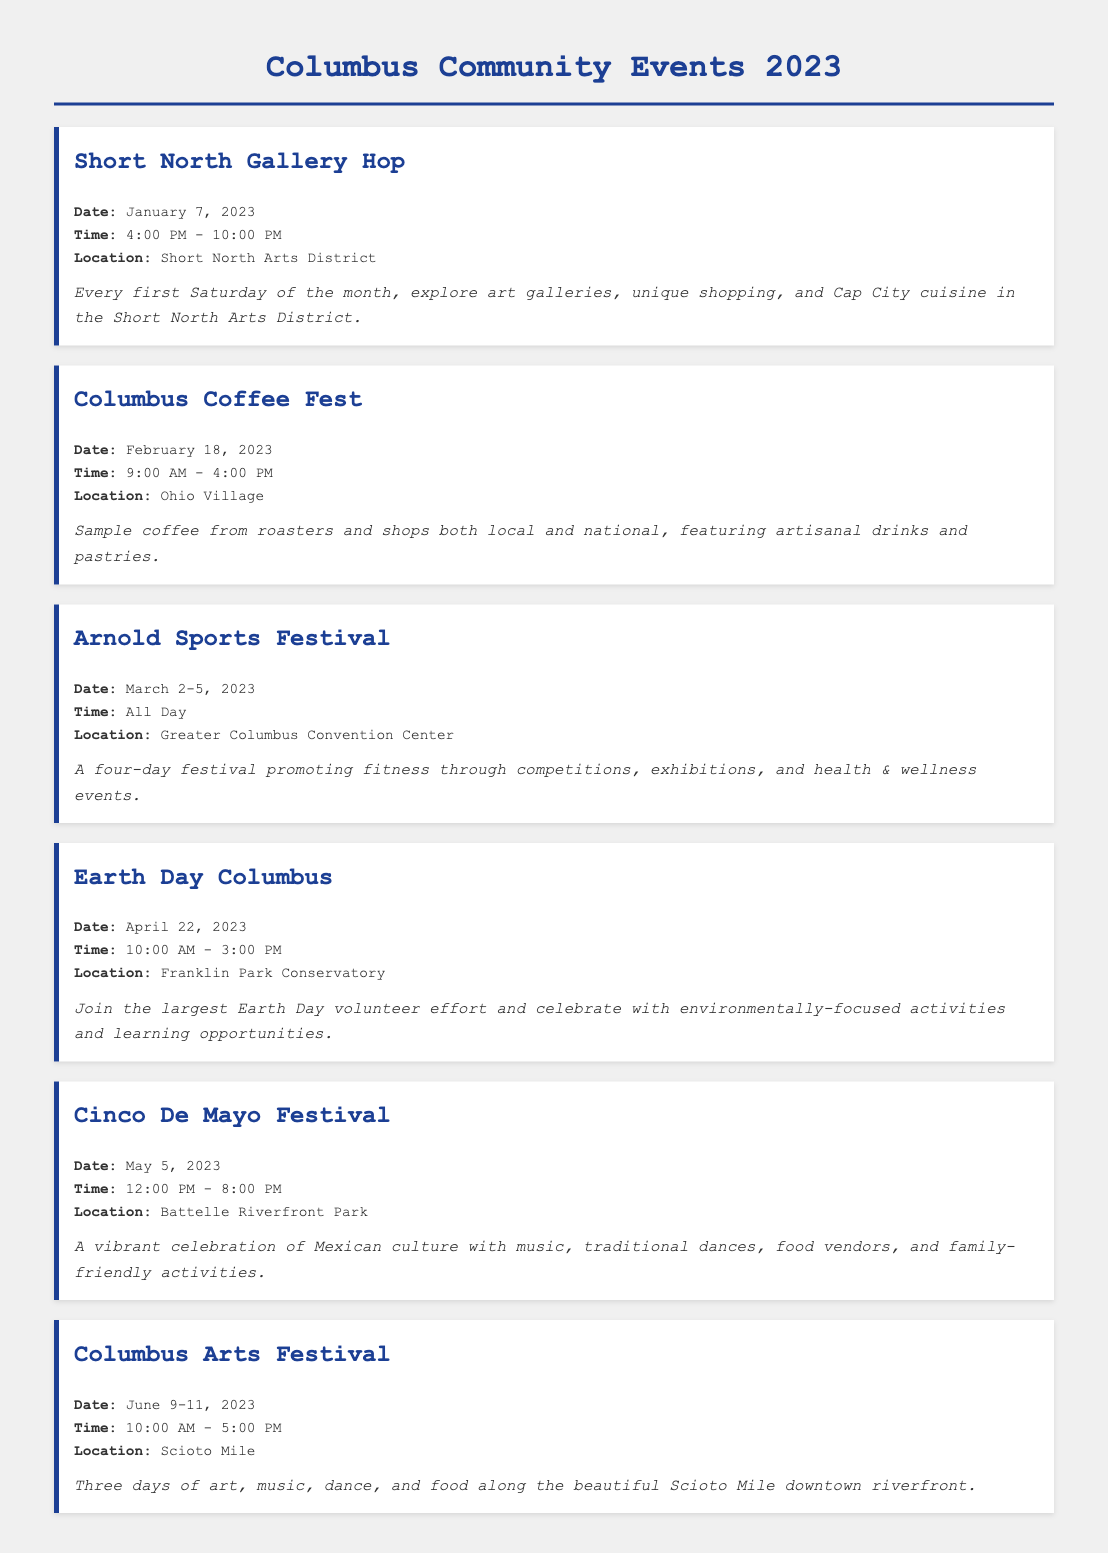What is the date of the Short North Gallery Hop? The date for the Short North Gallery Hop is specified in the document as January 7, 2023.
Answer: January 7, 2023 What time does the Columbus Coffee Fest start? The starting time for the Columbus Coffee Fest is listed as 9:00 AM in the document.
Answer: 9:00 AM Where is the Arnold Sports Festival held? The location of the Arnold Sports Festival is stated as the Greater Columbus Convention Center.
Answer: Greater Columbus Convention Center What type of activities can be expected at Earth Day Columbus? The document describes Earth Day Columbus activities as environmentally-focused activities and learning opportunities.
Answer: Environmentally-focused activities How long does the Columbus Arts Festival last? The duration of the Columbus Arts Festival is included as three days, from June 9 to June 11, 2023.
Answer: Three days Which festival celebrates Mexican culture? The document refers to the Cinco De Mayo Festival as the event that celebrates Mexican culture.
Answer: Cinco De Mayo Festival What is the time span of the Arnold Sports Festival? The time span covers several days, specifically March 2-5, 2023, as mentioned in the document.
Answer: March 2-5, 2023 What park hosts the Cinco De Mayo Festival? According to the document, the Cinco De Mayo Festival is hosted at Battelle Riverfront Park.
Answer: Battelle Riverfront Park 